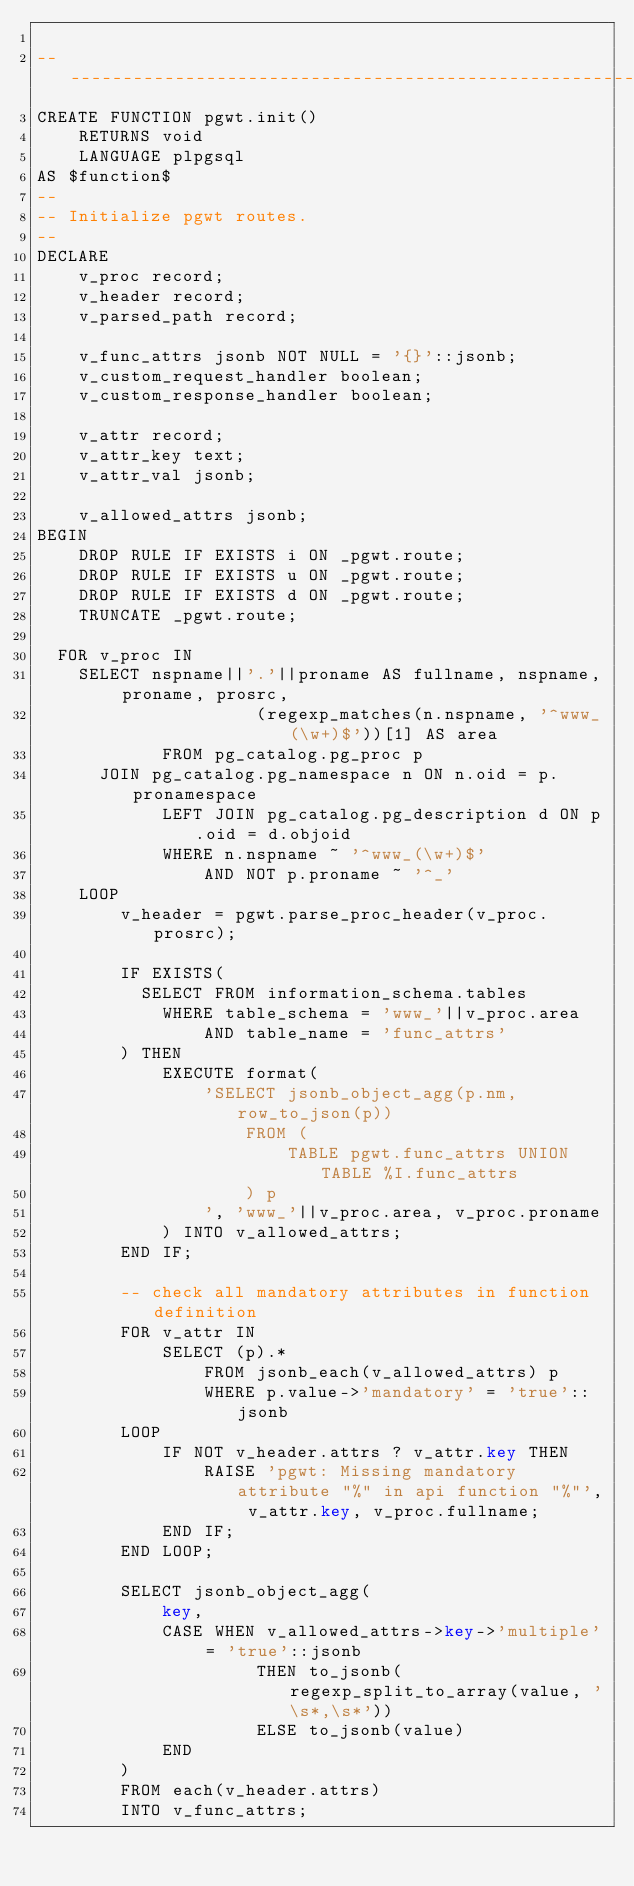Convert code to text. <code><loc_0><loc_0><loc_500><loc_500><_SQL_>
--------------------------------------------------------------------------------
CREATE FUNCTION pgwt.init()
	RETURNS void
	LANGUAGE plpgsql
AS $function$
--
-- Initialize pgwt routes.
--
DECLARE
	v_proc record;
	v_header record;
	v_parsed_path record;

	v_func_attrs jsonb NOT NULL = '{}'::jsonb;
	v_custom_request_handler boolean;
	v_custom_response_handler boolean;

	v_attr record;
	v_attr_key text;
	v_attr_val jsonb;

	v_allowed_attrs jsonb;
BEGIN
	DROP RULE IF EXISTS i ON _pgwt.route;
	DROP RULE IF EXISTS u ON _pgwt.route;
	DROP RULE IF EXISTS d ON _pgwt.route;
	TRUNCATE _pgwt.route;

  FOR v_proc IN
    SELECT nspname||'.'||proname AS fullname, nspname, proname, prosrc,
					 (regexp_matches(n.nspname, '^www_(\w+)$'))[1] AS area
			FROM pg_catalog.pg_proc p
      JOIN pg_catalog.pg_namespace n ON n.oid = p.pronamespace
			LEFT JOIN pg_catalog.pg_description d ON p.oid = d.objoid
			WHERE n.nspname ~ '^www_(\w+)$'
				AND NOT p.proname ~ '^_'
	LOOP
		v_header = pgwt.parse_proc_header(v_proc.prosrc);

		IF EXISTS(
		  SELECT FROM information_schema.tables
		   	WHERE table_schema = 'www_'||v_proc.area
		   		AND table_name = 'func_attrs'
		) THEN
			EXECUTE format(
				'SELECT jsonb_object_agg(p.nm, row_to_json(p))
					FROM (
						TABLE pgwt.func_attrs UNION TABLE %I.func_attrs
					) p
				', 'www_'||v_proc.area, v_proc.proname
			) INTO v_allowed_attrs;
		END IF;

		-- check all mandatory attributes in function definition
		FOR v_attr IN
			SELECT (p).*
				FROM jsonb_each(v_allowed_attrs) p
				WHERE p.value->'mandatory' = 'true'::jsonb
		LOOP
			IF NOT v_header.attrs ? v_attr.key THEN
				RAISE 'pgwt: Missing mandatory attribute "%" in api function "%"', v_attr.key, v_proc.fullname;
			END IF;
		END LOOP;

		SELECT jsonb_object_agg(
			key,
			CASE WHEN v_allowed_attrs->key->'multiple' = 'true'::jsonb
					 THEN to_jsonb(regexp_split_to_array(value, '\s*,\s*'))
					 ELSE to_jsonb(value)
			END
		)
		FROM each(v_header.attrs)
		INTO v_func_attrs;
</code> 